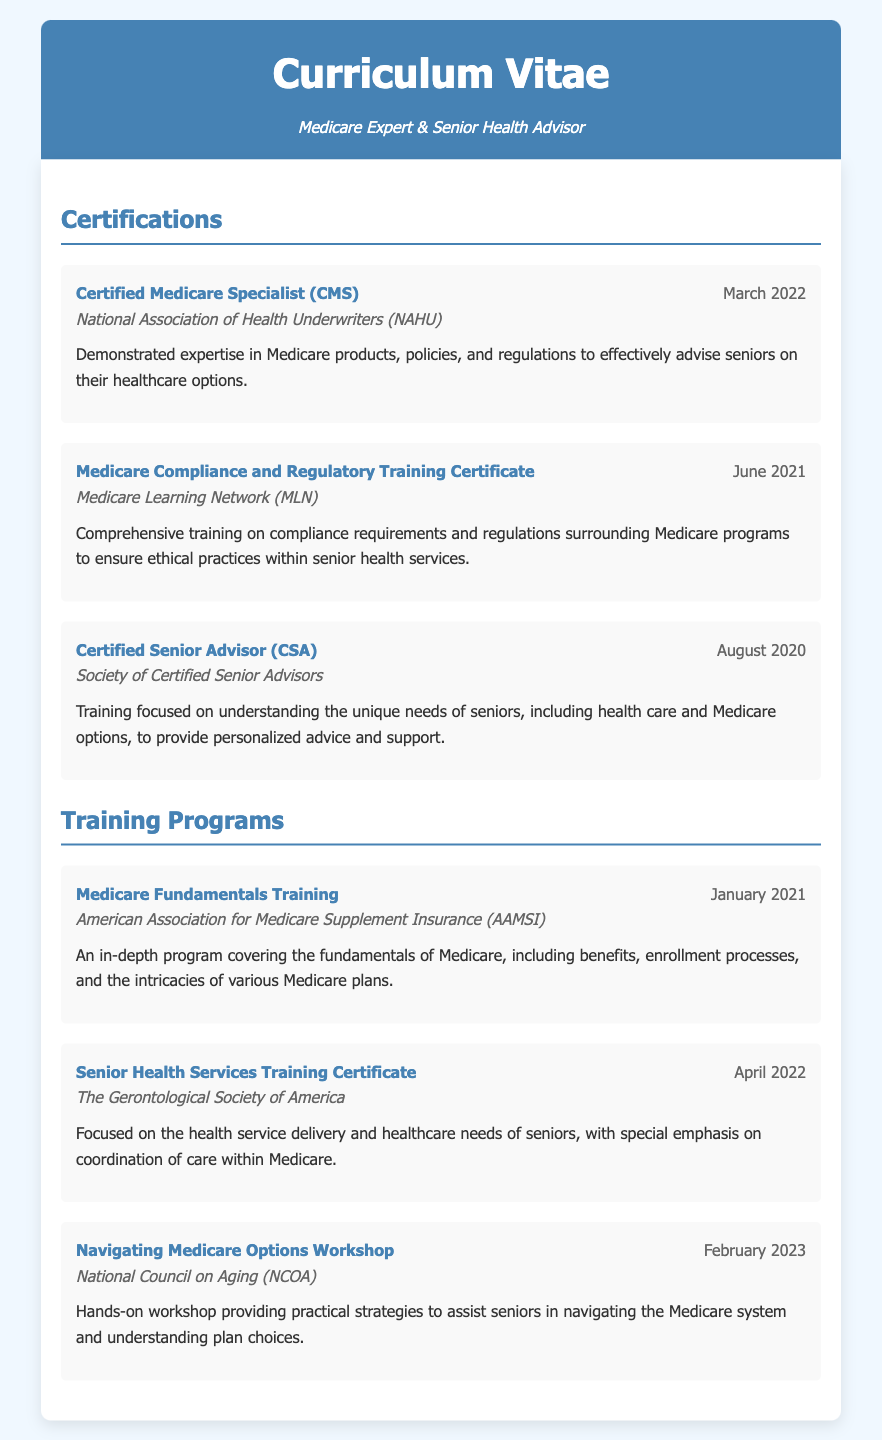What is the name of the first certification listed? The first certification listed is "Certified Medicare Specialist (CMS)."
Answer: Certified Medicare Specialist (CMS) When did the Certified Senior Advisor training occur? The Certified Senior Advisor training occurred in August 2020.
Answer: August 2020 Who provided the Medicare Compliance and Regulatory Training Certificate? The Medicare Compliance and Regulatory Training Certificate was provided by the Medicare Learning Network (MLN).
Answer: Medicare Learning Network (MLN) What is the focus of the "Senior Health Services Training Certificate"? The focus of the "Senior Health Services Training Certificate" is on health service delivery and healthcare needs of seniors.
Answer: health service delivery and healthcare needs of seniors How many certifications are listed in total? There are three certifications listed in total.
Answer: three What kind of training does the "Navigating Medicare Options Workshop" provide? The "Navigating Medicare Options Workshop" provides practical strategies to assist seniors in navigating the Medicare system.
Answer: practical strategies Which organization conducted the Medicare Fundamentals Training? The American Association for Medicare Supplement Insurance (AAMSI) conducted the Medicare Fundamentals Training.
Answer: American Association for Medicare Supplement Insurance (AAMSI) What is the date of the last training listed? The last training listed is dated February 2023.
Answer: February 2023 